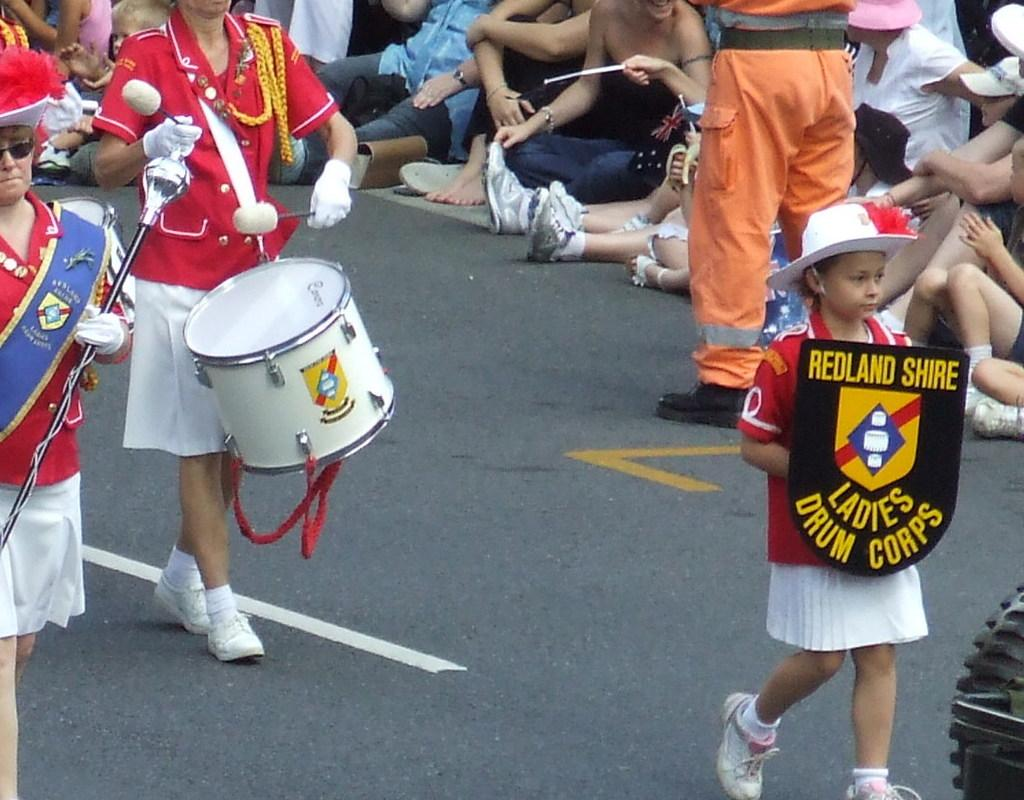<image>
Share a concise interpretation of the image provided. A child is walking in a parade holding a ladies drum corps sign 